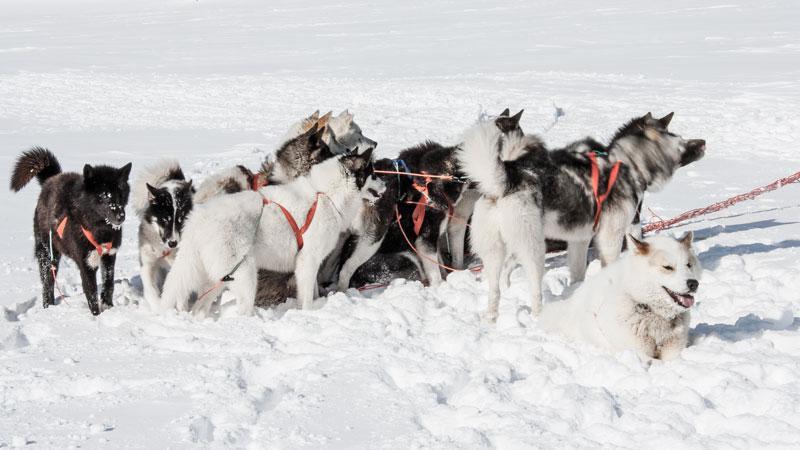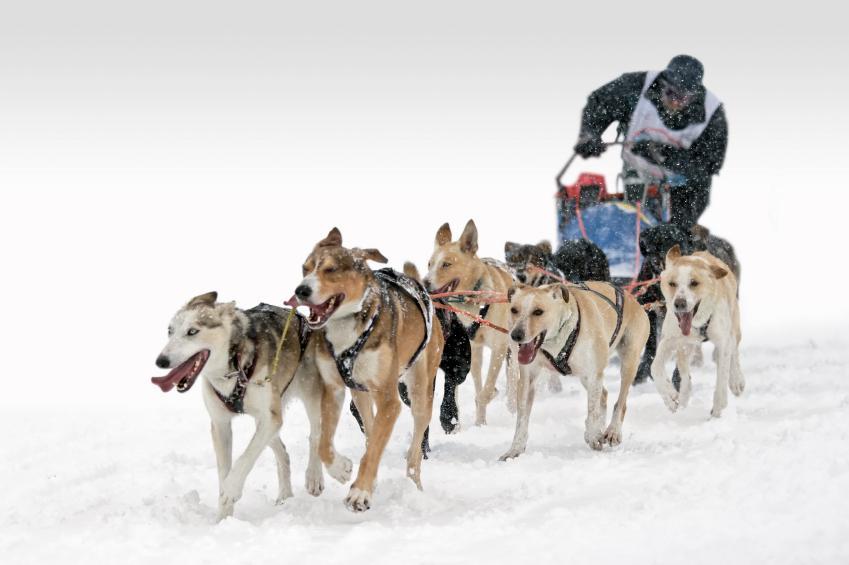The first image is the image on the left, the second image is the image on the right. Analyze the images presented: Is the assertion "There is only one human visible in the pair of images." valid? Answer yes or no. Yes. The first image is the image on the left, the second image is the image on the right. Examine the images to the left and right. Is the description "The teams of dogs in the left and right images are headed in the same direction." accurate? Answer yes or no. No. 